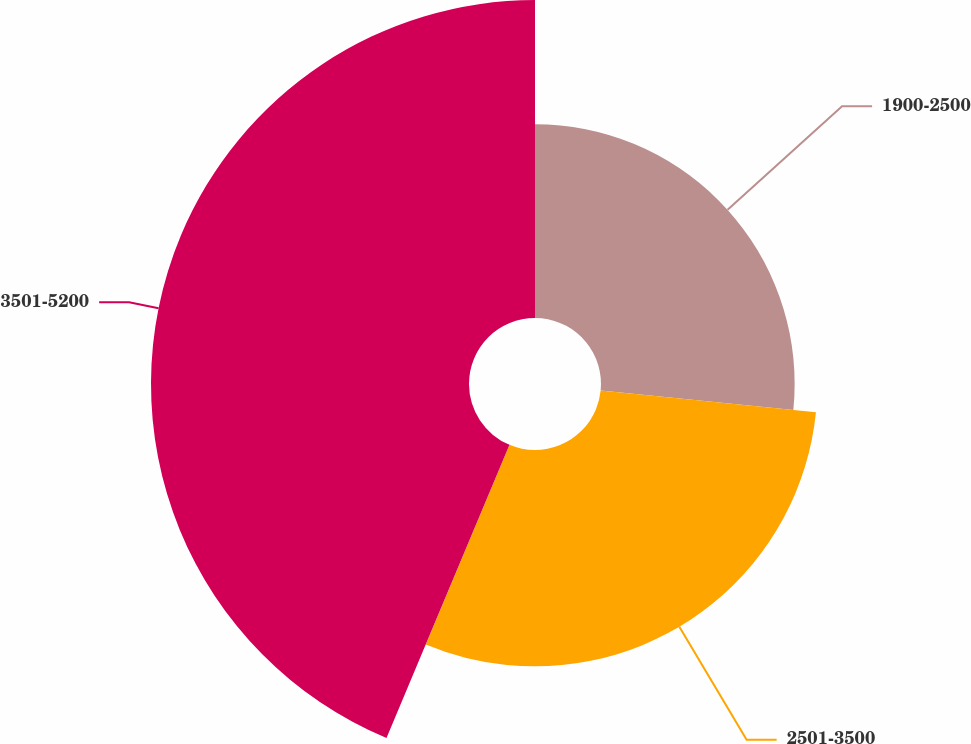Convert chart. <chart><loc_0><loc_0><loc_500><loc_500><pie_chart><fcel>1900-2500<fcel>2501-3500<fcel>3501-5200<nl><fcel>26.6%<fcel>29.72%<fcel>43.68%<nl></chart> 